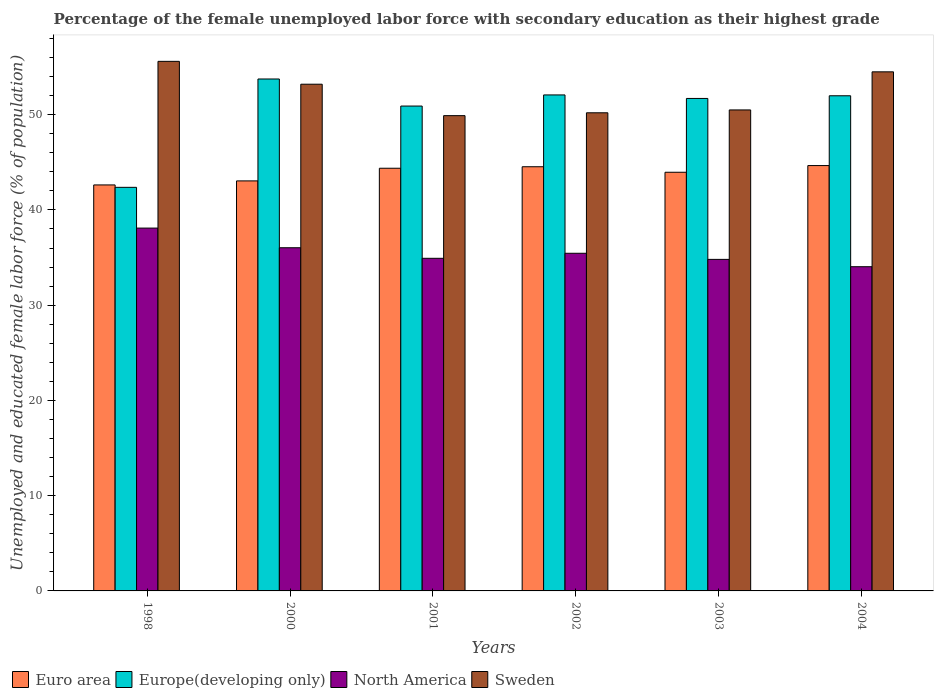Are the number of bars on each tick of the X-axis equal?
Offer a very short reply. Yes. What is the label of the 5th group of bars from the left?
Your response must be concise. 2003. In how many cases, is the number of bars for a given year not equal to the number of legend labels?
Your response must be concise. 0. What is the percentage of the unemployed female labor force with secondary education in North America in 2003?
Give a very brief answer. 34.81. Across all years, what is the maximum percentage of the unemployed female labor force with secondary education in Europe(developing only)?
Ensure brevity in your answer.  53.75. Across all years, what is the minimum percentage of the unemployed female labor force with secondary education in Europe(developing only)?
Provide a succinct answer. 42.37. What is the total percentage of the unemployed female labor force with secondary education in North America in the graph?
Give a very brief answer. 213.34. What is the difference between the percentage of the unemployed female labor force with secondary education in Euro area in 1998 and that in 2000?
Offer a very short reply. -0.42. What is the difference between the percentage of the unemployed female labor force with secondary education in North America in 2000 and the percentage of the unemployed female labor force with secondary education in Euro area in 2004?
Provide a short and direct response. -8.63. What is the average percentage of the unemployed female labor force with secondary education in North America per year?
Your answer should be compact. 35.56. In the year 2001, what is the difference between the percentage of the unemployed female labor force with secondary education in Europe(developing only) and percentage of the unemployed female labor force with secondary education in Euro area?
Your answer should be compact. 6.53. What is the ratio of the percentage of the unemployed female labor force with secondary education in North America in 2002 to that in 2004?
Offer a very short reply. 1.04. Is the percentage of the unemployed female labor force with secondary education in Euro area in 2002 less than that in 2003?
Offer a very short reply. No. What is the difference between the highest and the second highest percentage of the unemployed female labor force with secondary education in North America?
Offer a very short reply. 2.06. What is the difference between the highest and the lowest percentage of the unemployed female labor force with secondary education in Europe(developing only)?
Provide a short and direct response. 11.37. Is the sum of the percentage of the unemployed female labor force with secondary education in Sweden in 2001 and 2002 greater than the maximum percentage of the unemployed female labor force with secondary education in North America across all years?
Give a very brief answer. Yes. What does the 2nd bar from the left in 2001 represents?
Make the answer very short. Europe(developing only). What does the 2nd bar from the right in 2001 represents?
Your answer should be compact. North America. Is it the case that in every year, the sum of the percentage of the unemployed female labor force with secondary education in Euro area and percentage of the unemployed female labor force with secondary education in Europe(developing only) is greater than the percentage of the unemployed female labor force with secondary education in North America?
Your answer should be very brief. Yes. How many bars are there?
Your response must be concise. 24. Are all the bars in the graph horizontal?
Offer a terse response. No. What is the difference between two consecutive major ticks on the Y-axis?
Offer a terse response. 10. Does the graph contain any zero values?
Your answer should be compact. No. Does the graph contain grids?
Your answer should be compact. No. Where does the legend appear in the graph?
Your response must be concise. Bottom left. How are the legend labels stacked?
Ensure brevity in your answer.  Horizontal. What is the title of the graph?
Provide a succinct answer. Percentage of the female unemployed labor force with secondary education as their highest grade. What is the label or title of the X-axis?
Your response must be concise. Years. What is the label or title of the Y-axis?
Offer a terse response. Unemployed and educated female labor force (% of population). What is the Unemployed and educated female labor force (% of population) in Euro area in 1998?
Your response must be concise. 42.63. What is the Unemployed and educated female labor force (% of population) of Europe(developing only) in 1998?
Make the answer very short. 42.37. What is the Unemployed and educated female labor force (% of population) of North America in 1998?
Your answer should be very brief. 38.09. What is the Unemployed and educated female labor force (% of population) of Sweden in 1998?
Provide a short and direct response. 55.6. What is the Unemployed and educated female labor force (% of population) in Euro area in 2000?
Your answer should be compact. 43.05. What is the Unemployed and educated female labor force (% of population) in Europe(developing only) in 2000?
Offer a very short reply. 53.75. What is the Unemployed and educated female labor force (% of population) of North America in 2000?
Provide a succinct answer. 36.03. What is the Unemployed and educated female labor force (% of population) in Sweden in 2000?
Your answer should be very brief. 53.2. What is the Unemployed and educated female labor force (% of population) of Euro area in 2001?
Offer a very short reply. 44.38. What is the Unemployed and educated female labor force (% of population) in Europe(developing only) in 2001?
Your response must be concise. 50.91. What is the Unemployed and educated female labor force (% of population) of North America in 2001?
Offer a terse response. 34.92. What is the Unemployed and educated female labor force (% of population) of Sweden in 2001?
Your answer should be compact. 49.9. What is the Unemployed and educated female labor force (% of population) of Euro area in 2002?
Offer a very short reply. 44.53. What is the Unemployed and educated female labor force (% of population) in Europe(developing only) in 2002?
Your answer should be very brief. 52.07. What is the Unemployed and educated female labor force (% of population) in North America in 2002?
Provide a short and direct response. 35.45. What is the Unemployed and educated female labor force (% of population) in Sweden in 2002?
Give a very brief answer. 50.2. What is the Unemployed and educated female labor force (% of population) of Euro area in 2003?
Your answer should be very brief. 43.96. What is the Unemployed and educated female labor force (% of population) of Europe(developing only) in 2003?
Ensure brevity in your answer.  51.71. What is the Unemployed and educated female labor force (% of population) of North America in 2003?
Offer a very short reply. 34.81. What is the Unemployed and educated female labor force (% of population) in Sweden in 2003?
Give a very brief answer. 50.5. What is the Unemployed and educated female labor force (% of population) of Euro area in 2004?
Give a very brief answer. 44.66. What is the Unemployed and educated female labor force (% of population) of Europe(developing only) in 2004?
Offer a terse response. 51.99. What is the Unemployed and educated female labor force (% of population) of North America in 2004?
Offer a very short reply. 34.04. What is the Unemployed and educated female labor force (% of population) in Sweden in 2004?
Offer a very short reply. 54.5. Across all years, what is the maximum Unemployed and educated female labor force (% of population) in Euro area?
Your response must be concise. 44.66. Across all years, what is the maximum Unemployed and educated female labor force (% of population) of Europe(developing only)?
Offer a very short reply. 53.75. Across all years, what is the maximum Unemployed and educated female labor force (% of population) of North America?
Ensure brevity in your answer.  38.09. Across all years, what is the maximum Unemployed and educated female labor force (% of population) in Sweden?
Your answer should be very brief. 55.6. Across all years, what is the minimum Unemployed and educated female labor force (% of population) of Euro area?
Offer a terse response. 42.63. Across all years, what is the minimum Unemployed and educated female labor force (% of population) in Europe(developing only)?
Make the answer very short. 42.37. Across all years, what is the minimum Unemployed and educated female labor force (% of population) of North America?
Your response must be concise. 34.04. Across all years, what is the minimum Unemployed and educated female labor force (% of population) of Sweden?
Offer a terse response. 49.9. What is the total Unemployed and educated female labor force (% of population) of Euro area in the graph?
Provide a succinct answer. 263.2. What is the total Unemployed and educated female labor force (% of population) of Europe(developing only) in the graph?
Make the answer very short. 302.79. What is the total Unemployed and educated female labor force (% of population) of North America in the graph?
Keep it short and to the point. 213.34. What is the total Unemployed and educated female labor force (% of population) in Sweden in the graph?
Give a very brief answer. 313.9. What is the difference between the Unemployed and educated female labor force (% of population) in Euro area in 1998 and that in 2000?
Offer a terse response. -0.42. What is the difference between the Unemployed and educated female labor force (% of population) in Europe(developing only) in 1998 and that in 2000?
Keep it short and to the point. -11.37. What is the difference between the Unemployed and educated female labor force (% of population) of North America in 1998 and that in 2000?
Your answer should be very brief. 2.06. What is the difference between the Unemployed and educated female labor force (% of population) in Sweden in 1998 and that in 2000?
Ensure brevity in your answer.  2.4. What is the difference between the Unemployed and educated female labor force (% of population) of Euro area in 1998 and that in 2001?
Keep it short and to the point. -1.75. What is the difference between the Unemployed and educated female labor force (% of population) in Europe(developing only) in 1998 and that in 2001?
Offer a very short reply. -8.53. What is the difference between the Unemployed and educated female labor force (% of population) in North America in 1998 and that in 2001?
Offer a very short reply. 3.17. What is the difference between the Unemployed and educated female labor force (% of population) of Euro area in 1998 and that in 2002?
Provide a short and direct response. -1.91. What is the difference between the Unemployed and educated female labor force (% of population) of Europe(developing only) in 1998 and that in 2002?
Offer a terse response. -9.7. What is the difference between the Unemployed and educated female labor force (% of population) in North America in 1998 and that in 2002?
Make the answer very short. 2.64. What is the difference between the Unemployed and educated female labor force (% of population) of Euro area in 1998 and that in 2003?
Offer a very short reply. -1.33. What is the difference between the Unemployed and educated female labor force (% of population) in Europe(developing only) in 1998 and that in 2003?
Ensure brevity in your answer.  -9.33. What is the difference between the Unemployed and educated female labor force (% of population) of North America in 1998 and that in 2003?
Your answer should be compact. 3.29. What is the difference between the Unemployed and educated female labor force (% of population) of Sweden in 1998 and that in 2003?
Offer a terse response. 5.1. What is the difference between the Unemployed and educated female labor force (% of population) in Euro area in 1998 and that in 2004?
Ensure brevity in your answer.  -2.03. What is the difference between the Unemployed and educated female labor force (% of population) of Europe(developing only) in 1998 and that in 2004?
Offer a terse response. -9.61. What is the difference between the Unemployed and educated female labor force (% of population) in North America in 1998 and that in 2004?
Make the answer very short. 4.05. What is the difference between the Unemployed and educated female labor force (% of population) of Euro area in 2000 and that in 2001?
Make the answer very short. -1.33. What is the difference between the Unemployed and educated female labor force (% of population) in Europe(developing only) in 2000 and that in 2001?
Your answer should be very brief. 2.84. What is the difference between the Unemployed and educated female labor force (% of population) in North America in 2000 and that in 2001?
Your response must be concise. 1.11. What is the difference between the Unemployed and educated female labor force (% of population) of Euro area in 2000 and that in 2002?
Make the answer very short. -1.48. What is the difference between the Unemployed and educated female labor force (% of population) of Europe(developing only) in 2000 and that in 2002?
Your answer should be very brief. 1.67. What is the difference between the Unemployed and educated female labor force (% of population) in North America in 2000 and that in 2002?
Offer a very short reply. 0.58. What is the difference between the Unemployed and educated female labor force (% of population) in Sweden in 2000 and that in 2002?
Ensure brevity in your answer.  3. What is the difference between the Unemployed and educated female labor force (% of population) in Euro area in 2000 and that in 2003?
Provide a succinct answer. -0.91. What is the difference between the Unemployed and educated female labor force (% of population) of Europe(developing only) in 2000 and that in 2003?
Keep it short and to the point. 2.04. What is the difference between the Unemployed and educated female labor force (% of population) of North America in 2000 and that in 2003?
Your answer should be compact. 1.22. What is the difference between the Unemployed and educated female labor force (% of population) of Sweden in 2000 and that in 2003?
Make the answer very short. 2.7. What is the difference between the Unemployed and educated female labor force (% of population) of Euro area in 2000 and that in 2004?
Keep it short and to the point. -1.61. What is the difference between the Unemployed and educated female labor force (% of population) in Europe(developing only) in 2000 and that in 2004?
Provide a succinct answer. 1.76. What is the difference between the Unemployed and educated female labor force (% of population) of North America in 2000 and that in 2004?
Give a very brief answer. 1.99. What is the difference between the Unemployed and educated female labor force (% of population) of Sweden in 2000 and that in 2004?
Give a very brief answer. -1.3. What is the difference between the Unemployed and educated female labor force (% of population) of Euro area in 2001 and that in 2002?
Your answer should be compact. -0.16. What is the difference between the Unemployed and educated female labor force (% of population) of Europe(developing only) in 2001 and that in 2002?
Offer a terse response. -1.17. What is the difference between the Unemployed and educated female labor force (% of population) in North America in 2001 and that in 2002?
Offer a terse response. -0.53. What is the difference between the Unemployed and educated female labor force (% of population) of Sweden in 2001 and that in 2002?
Give a very brief answer. -0.3. What is the difference between the Unemployed and educated female labor force (% of population) of Euro area in 2001 and that in 2003?
Give a very brief answer. 0.42. What is the difference between the Unemployed and educated female labor force (% of population) in Europe(developing only) in 2001 and that in 2003?
Ensure brevity in your answer.  -0.8. What is the difference between the Unemployed and educated female labor force (% of population) of North America in 2001 and that in 2003?
Give a very brief answer. 0.11. What is the difference between the Unemployed and educated female labor force (% of population) in Sweden in 2001 and that in 2003?
Your answer should be very brief. -0.6. What is the difference between the Unemployed and educated female labor force (% of population) in Euro area in 2001 and that in 2004?
Your answer should be compact. -0.28. What is the difference between the Unemployed and educated female labor force (% of population) of Europe(developing only) in 2001 and that in 2004?
Your response must be concise. -1.08. What is the difference between the Unemployed and educated female labor force (% of population) of North America in 2001 and that in 2004?
Offer a terse response. 0.88. What is the difference between the Unemployed and educated female labor force (% of population) in Sweden in 2001 and that in 2004?
Your answer should be compact. -4.6. What is the difference between the Unemployed and educated female labor force (% of population) of Euro area in 2002 and that in 2003?
Your answer should be compact. 0.58. What is the difference between the Unemployed and educated female labor force (% of population) of Europe(developing only) in 2002 and that in 2003?
Provide a succinct answer. 0.37. What is the difference between the Unemployed and educated female labor force (% of population) of North America in 2002 and that in 2003?
Provide a short and direct response. 0.64. What is the difference between the Unemployed and educated female labor force (% of population) of Euro area in 2002 and that in 2004?
Provide a succinct answer. -0.12. What is the difference between the Unemployed and educated female labor force (% of population) of Europe(developing only) in 2002 and that in 2004?
Ensure brevity in your answer.  0.09. What is the difference between the Unemployed and educated female labor force (% of population) in North America in 2002 and that in 2004?
Provide a succinct answer. 1.41. What is the difference between the Unemployed and educated female labor force (% of population) in Euro area in 2003 and that in 2004?
Keep it short and to the point. -0.7. What is the difference between the Unemployed and educated female labor force (% of population) in Europe(developing only) in 2003 and that in 2004?
Provide a short and direct response. -0.28. What is the difference between the Unemployed and educated female labor force (% of population) in North America in 2003 and that in 2004?
Your answer should be compact. 0.77. What is the difference between the Unemployed and educated female labor force (% of population) in Euro area in 1998 and the Unemployed and educated female labor force (% of population) in Europe(developing only) in 2000?
Make the answer very short. -11.12. What is the difference between the Unemployed and educated female labor force (% of population) of Euro area in 1998 and the Unemployed and educated female labor force (% of population) of North America in 2000?
Your answer should be very brief. 6.59. What is the difference between the Unemployed and educated female labor force (% of population) of Euro area in 1998 and the Unemployed and educated female labor force (% of population) of Sweden in 2000?
Make the answer very short. -10.57. What is the difference between the Unemployed and educated female labor force (% of population) of Europe(developing only) in 1998 and the Unemployed and educated female labor force (% of population) of North America in 2000?
Give a very brief answer. 6.34. What is the difference between the Unemployed and educated female labor force (% of population) of Europe(developing only) in 1998 and the Unemployed and educated female labor force (% of population) of Sweden in 2000?
Your answer should be very brief. -10.83. What is the difference between the Unemployed and educated female labor force (% of population) in North America in 1998 and the Unemployed and educated female labor force (% of population) in Sweden in 2000?
Keep it short and to the point. -15.11. What is the difference between the Unemployed and educated female labor force (% of population) in Euro area in 1998 and the Unemployed and educated female labor force (% of population) in Europe(developing only) in 2001?
Your answer should be compact. -8.28. What is the difference between the Unemployed and educated female labor force (% of population) in Euro area in 1998 and the Unemployed and educated female labor force (% of population) in North America in 2001?
Offer a very short reply. 7.7. What is the difference between the Unemployed and educated female labor force (% of population) in Euro area in 1998 and the Unemployed and educated female labor force (% of population) in Sweden in 2001?
Your response must be concise. -7.27. What is the difference between the Unemployed and educated female labor force (% of population) of Europe(developing only) in 1998 and the Unemployed and educated female labor force (% of population) of North America in 2001?
Your response must be concise. 7.45. What is the difference between the Unemployed and educated female labor force (% of population) of Europe(developing only) in 1998 and the Unemployed and educated female labor force (% of population) of Sweden in 2001?
Make the answer very short. -7.53. What is the difference between the Unemployed and educated female labor force (% of population) in North America in 1998 and the Unemployed and educated female labor force (% of population) in Sweden in 2001?
Your answer should be very brief. -11.81. What is the difference between the Unemployed and educated female labor force (% of population) of Euro area in 1998 and the Unemployed and educated female labor force (% of population) of Europe(developing only) in 2002?
Provide a short and direct response. -9.45. What is the difference between the Unemployed and educated female labor force (% of population) of Euro area in 1998 and the Unemployed and educated female labor force (% of population) of North America in 2002?
Your answer should be very brief. 7.18. What is the difference between the Unemployed and educated female labor force (% of population) of Euro area in 1998 and the Unemployed and educated female labor force (% of population) of Sweden in 2002?
Make the answer very short. -7.57. What is the difference between the Unemployed and educated female labor force (% of population) in Europe(developing only) in 1998 and the Unemployed and educated female labor force (% of population) in North America in 2002?
Your answer should be very brief. 6.92. What is the difference between the Unemployed and educated female labor force (% of population) in Europe(developing only) in 1998 and the Unemployed and educated female labor force (% of population) in Sweden in 2002?
Provide a short and direct response. -7.83. What is the difference between the Unemployed and educated female labor force (% of population) of North America in 1998 and the Unemployed and educated female labor force (% of population) of Sweden in 2002?
Offer a very short reply. -12.11. What is the difference between the Unemployed and educated female labor force (% of population) of Euro area in 1998 and the Unemployed and educated female labor force (% of population) of Europe(developing only) in 2003?
Your answer should be compact. -9.08. What is the difference between the Unemployed and educated female labor force (% of population) of Euro area in 1998 and the Unemployed and educated female labor force (% of population) of North America in 2003?
Provide a short and direct response. 7.82. What is the difference between the Unemployed and educated female labor force (% of population) in Euro area in 1998 and the Unemployed and educated female labor force (% of population) in Sweden in 2003?
Ensure brevity in your answer.  -7.87. What is the difference between the Unemployed and educated female labor force (% of population) in Europe(developing only) in 1998 and the Unemployed and educated female labor force (% of population) in North America in 2003?
Ensure brevity in your answer.  7.56. What is the difference between the Unemployed and educated female labor force (% of population) in Europe(developing only) in 1998 and the Unemployed and educated female labor force (% of population) in Sweden in 2003?
Give a very brief answer. -8.13. What is the difference between the Unemployed and educated female labor force (% of population) of North America in 1998 and the Unemployed and educated female labor force (% of population) of Sweden in 2003?
Provide a succinct answer. -12.41. What is the difference between the Unemployed and educated female labor force (% of population) in Euro area in 1998 and the Unemployed and educated female labor force (% of population) in Europe(developing only) in 2004?
Your answer should be compact. -9.36. What is the difference between the Unemployed and educated female labor force (% of population) in Euro area in 1998 and the Unemployed and educated female labor force (% of population) in North America in 2004?
Your response must be concise. 8.59. What is the difference between the Unemployed and educated female labor force (% of population) in Euro area in 1998 and the Unemployed and educated female labor force (% of population) in Sweden in 2004?
Your answer should be compact. -11.87. What is the difference between the Unemployed and educated female labor force (% of population) in Europe(developing only) in 1998 and the Unemployed and educated female labor force (% of population) in North America in 2004?
Your response must be concise. 8.33. What is the difference between the Unemployed and educated female labor force (% of population) of Europe(developing only) in 1998 and the Unemployed and educated female labor force (% of population) of Sweden in 2004?
Your answer should be very brief. -12.13. What is the difference between the Unemployed and educated female labor force (% of population) of North America in 1998 and the Unemployed and educated female labor force (% of population) of Sweden in 2004?
Make the answer very short. -16.41. What is the difference between the Unemployed and educated female labor force (% of population) of Euro area in 2000 and the Unemployed and educated female labor force (% of population) of Europe(developing only) in 2001?
Your response must be concise. -7.86. What is the difference between the Unemployed and educated female labor force (% of population) in Euro area in 2000 and the Unemployed and educated female labor force (% of population) in North America in 2001?
Provide a succinct answer. 8.13. What is the difference between the Unemployed and educated female labor force (% of population) in Euro area in 2000 and the Unemployed and educated female labor force (% of population) in Sweden in 2001?
Offer a terse response. -6.85. What is the difference between the Unemployed and educated female labor force (% of population) in Europe(developing only) in 2000 and the Unemployed and educated female labor force (% of population) in North America in 2001?
Keep it short and to the point. 18.83. What is the difference between the Unemployed and educated female labor force (% of population) of Europe(developing only) in 2000 and the Unemployed and educated female labor force (% of population) of Sweden in 2001?
Your response must be concise. 3.85. What is the difference between the Unemployed and educated female labor force (% of population) in North America in 2000 and the Unemployed and educated female labor force (% of population) in Sweden in 2001?
Your answer should be compact. -13.87. What is the difference between the Unemployed and educated female labor force (% of population) of Euro area in 2000 and the Unemployed and educated female labor force (% of population) of Europe(developing only) in 2002?
Offer a very short reply. -9.03. What is the difference between the Unemployed and educated female labor force (% of population) in Euro area in 2000 and the Unemployed and educated female labor force (% of population) in North America in 2002?
Offer a terse response. 7.6. What is the difference between the Unemployed and educated female labor force (% of population) in Euro area in 2000 and the Unemployed and educated female labor force (% of population) in Sweden in 2002?
Your response must be concise. -7.15. What is the difference between the Unemployed and educated female labor force (% of population) in Europe(developing only) in 2000 and the Unemployed and educated female labor force (% of population) in North America in 2002?
Provide a short and direct response. 18.3. What is the difference between the Unemployed and educated female labor force (% of population) in Europe(developing only) in 2000 and the Unemployed and educated female labor force (% of population) in Sweden in 2002?
Your answer should be very brief. 3.55. What is the difference between the Unemployed and educated female labor force (% of population) in North America in 2000 and the Unemployed and educated female labor force (% of population) in Sweden in 2002?
Make the answer very short. -14.17. What is the difference between the Unemployed and educated female labor force (% of population) in Euro area in 2000 and the Unemployed and educated female labor force (% of population) in Europe(developing only) in 2003?
Keep it short and to the point. -8.66. What is the difference between the Unemployed and educated female labor force (% of population) of Euro area in 2000 and the Unemployed and educated female labor force (% of population) of North America in 2003?
Keep it short and to the point. 8.24. What is the difference between the Unemployed and educated female labor force (% of population) of Euro area in 2000 and the Unemployed and educated female labor force (% of population) of Sweden in 2003?
Your response must be concise. -7.45. What is the difference between the Unemployed and educated female labor force (% of population) of Europe(developing only) in 2000 and the Unemployed and educated female labor force (% of population) of North America in 2003?
Provide a short and direct response. 18.94. What is the difference between the Unemployed and educated female labor force (% of population) of Europe(developing only) in 2000 and the Unemployed and educated female labor force (% of population) of Sweden in 2003?
Provide a short and direct response. 3.25. What is the difference between the Unemployed and educated female labor force (% of population) in North America in 2000 and the Unemployed and educated female labor force (% of population) in Sweden in 2003?
Keep it short and to the point. -14.47. What is the difference between the Unemployed and educated female labor force (% of population) in Euro area in 2000 and the Unemployed and educated female labor force (% of population) in Europe(developing only) in 2004?
Give a very brief answer. -8.94. What is the difference between the Unemployed and educated female labor force (% of population) in Euro area in 2000 and the Unemployed and educated female labor force (% of population) in North America in 2004?
Give a very brief answer. 9.01. What is the difference between the Unemployed and educated female labor force (% of population) in Euro area in 2000 and the Unemployed and educated female labor force (% of population) in Sweden in 2004?
Keep it short and to the point. -11.45. What is the difference between the Unemployed and educated female labor force (% of population) of Europe(developing only) in 2000 and the Unemployed and educated female labor force (% of population) of North America in 2004?
Provide a succinct answer. 19.71. What is the difference between the Unemployed and educated female labor force (% of population) in Europe(developing only) in 2000 and the Unemployed and educated female labor force (% of population) in Sweden in 2004?
Your answer should be compact. -0.75. What is the difference between the Unemployed and educated female labor force (% of population) in North America in 2000 and the Unemployed and educated female labor force (% of population) in Sweden in 2004?
Your answer should be very brief. -18.47. What is the difference between the Unemployed and educated female labor force (% of population) in Euro area in 2001 and the Unemployed and educated female labor force (% of population) in Europe(developing only) in 2002?
Your response must be concise. -7.7. What is the difference between the Unemployed and educated female labor force (% of population) of Euro area in 2001 and the Unemployed and educated female labor force (% of population) of North America in 2002?
Provide a succinct answer. 8.93. What is the difference between the Unemployed and educated female labor force (% of population) of Euro area in 2001 and the Unemployed and educated female labor force (% of population) of Sweden in 2002?
Your response must be concise. -5.82. What is the difference between the Unemployed and educated female labor force (% of population) of Europe(developing only) in 2001 and the Unemployed and educated female labor force (% of population) of North America in 2002?
Your answer should be compact. 15.46. What is the difference between the Unemployed and educated female labor force (% of population) in Europe(developing only) in 2001 and the Unemployed and educated female labor force (% of population) in Sweden in 2002?
Keep it short and to the point. 0.71. What is the difference between the Unemployed and educated female labor force (% of population) in North America in 2001 and the Unemployed and educated female labor force (% of population) in Sweden in 2002?
Your answer should be very brief. -15.28. What is the difference between the Unemployed and educated female labor force (% of population) of Euro area in 2001 and the Unemployed and educated female labor force (% of population) of Europe(developing only) in 2003?
Provide a short and direct response. -7.33. What is the difference between the Unemployed and educated female labor force (% of population) of Euro area in 2001 and the Unemployed and educated female labor force (% of population) of North America in 2003?
Offer a terse response. 9.57. What is the difference between the Unemployed and educated female labor force (% of population) in Euro area in 2001 and the Unemployed and educated female labor force (% of population) in Sweden in 2003?
Offer a very short reply. -6.12. What is the difference between the Unemployed and educated female labor force (% of population) of Europe(developing only) in 2001 and the Unemployed and educated female labor force (% of population) of North America in 2003?
Provide a succinct answer. 16.1. What is the difference between the Unemployed and educated female labor force (% of population) of Europe(developing only) in 2001 and the Unemployed and educated female labor force (% of population) of Sweden in 2003?
Your answer should be compact. 0.41. What is the difference between the Unemployed and educated female labor force (% of population) of North America in 2001 and the Unemployed and educated female labor force (% of population) of Sweden in 2003?
Keep it short and to the point. -15.58. What is the difference between the Unemployed and educated female labor force (% of population) in Euro area in 2001 and the Unemployed and educated female labor force (% of population) in Europe(developing only) in 2004?
Your answer should be compact. -7.61. What is the difference between the Unemployed and educated female labor force (% of population) of Euro area in 2001 and the Unemployed and educated female labor force (% of population) of North America in 2004?
Your answer should be compact. 10.34. What is the difference between the Unemployed and educated female labor force (% of population) of Euro area in 2001 and the Unemployed and educated female labor force (% of population) of Sweden in 2004?
Your response must be concise. -10.12. What is the difference between the Unemployed and educated female labor force (% of population) of Europe(developing only) in 2001 and the Unemployed and educated female labor force (% of population) of North America in 2004?
Ensure brevity in your answer.  16.87. What is the difference between the Unemployed and educated female labor force (% of population) in Europe(developing only) in 2001 and the Unemployed and educated female labor force (% of population) in Sweden in 2004?
Give a very brief answer. -3.59. What is the difference between the Unemployed and educated female labor force (% of population) in North America in 2001 and the Unemployed and educated female labor force (% of population) in Sweden in 2004?
Provide a short and direct response. -19.58. What is the difference between the Unemployed and educated female labor force (% of population) of Euro area in 2002 and the Unemployed and educated female labor force (% of population) of Europe(developing only) in 2003?
Offer a terse response. -7.17. What is the difference between the Unemployed and educated female labor force (% of population) of Euro area in 2002 and the Unemployed and educated female labor force (% of population) of North America in 2003?
Provide a short and direct response. 9.73. What is the difference between the Unemployed and educated female labor force (% of population) in Euro area in 2002 and the Unemployed and educated female labor force (% of population) in Sweden in 2003?
Ensure brevity in your answer.  -5.97. What is the difference between the Unemployed and educated female labor force (% of population) of Europe(developing only) in 2002 and the Unemployed and educated female labor force (% of population) of North America in 2003?
Provide a succinct answer. 17.27. What is the difference between the Unemployed and educated female labor force (% of population) in Europe(developing only) in 2002 and the Unemployed and educated female labor force (% of population) in Sweden in 2003?
Ensure brevity in your answer.  1.57. What is the difference between the Unemployed and educated female labor force (% of population) of North America in 2002 and the Unemployed and educated female labor force (% of population) of Sweden in 2003?
Provide a short and direct response. -15.05. What is the difference between the Unemployed and educated female labor force (% of population) of Euro area in 2002 and the Unemployed and educated female labor force (% of population) of Europe(developing only) in 2004?
Your response must be concise. -7.45. What is the difference between the Unemployed and educated female labor force (% of population) in Euro area in 2002 and the Unemployed and educated female labor force (% of population) in North America in 2004?
Make the answer very short. 10.5. What is the difference between the Unemployed and educated female labor force (% of population) in Euro area in 2002 and the Unemployed and educated female labor force (% of population) in Sweden in 2004?
Your answer should be very brief. -9.97. What is the difference between the Unemployed and educated female labor force (% of population) in Europe(developing only) in 2002 and the Unemployed and educated female labor force (% of population) in North America in 2004?
Ensure brevity in your answer.  18.04. What is the difference between the Unemployed and educated female labor force (% of population) of Europe(developing only) in 2002 and the Unemployed and educated female labor force (% of population) of Sweden in 2004?
Your answer should be very brief. -2.43. What is the difference between the Unemployed and educated female labor force (% of population) in North America in 2002 and the Unemployed and educated female labor force (% of population) in Sweden in 2004?
Keep it short and to the point. -19.05. What is the difference between the Unemployed and educated female labor force (% of population) of Euro area in 2003 and the Unemployed and educated female labor force (% of population) of Europe(developing only) in 2004?
Your answer should be very brief. -8.03. What is the difference between the Unemployed and educated female labor force (% of population) in Euro area in 2003 and the Unemployed and educated female labor force (% of population) in North America in 2004?
Keep it short and to the point. 9.92. What is the difference between the Unemployed and educated female labor force (% of population) of Euro area in 2003 and the Unemployed and educated female labor force (% of population) of Sweden in 2004?
Ensure brevity in your answer.  -10.54. What is the difference between the Unemployed and educated female labor force (% of population) in Europe(developing only) in 2003 and the Unemployed and educated female labor force (% of population) in North America in 2004?
Give a very brief answer. 17.67. What is the difference between the Unemployed and educated female labor force (% of population) in Europe(developing only) in 2003 and the Unemployed and educated female labor force (% of population) in Sweden in 2004?
Give a very brief answer. -2.79. What is the difference between the Unemployed and educated female labor force (% of population) of North America in 2003 and the Unemployed and educated female labor force (% of population) of Sweden in 2004?
Provide a succinct answer. -19.69. What is the average Unemployed and educated female labor force (% of population) of Euro area per year?
Make the answer very short. 43.87. What is the average Unemployed and educated female labor force (% of population) of Europe(developing only) per year?
Make the answer very short. 50.47. What is the average Unemployed and educated female labor force (% of population) of North America per year?
Give a very brief answer. 35.56. What is the average Unemployed and educated female labor force (% of population) in Sweden per year?
Offer a terse response. 52.32. In the year 1998, what is the difference between the Unemployed and educated female labor force (% of population) in Euro area and Unemployed and educated female labor force (% of population) in Europe(developing only)?
Your answer should be compact. 0.25. In the year 1998, what is the difference between the Unemployed and educated female labor force (% of population) of Euro area and Unemployed and educated female labor force (% of population) of North America?
Your answer should be very brief. 4.53. In the year 1998, what is the difference between the Unemployed and educated female labor force (% of population) of Euro area and Unemployed and educated female labor force (% of population) of Sweden?
Your answer should be compact. -12.97. In the year 1998, what is the difference between the Unemployed and educated female labor force (% of population) of Europe(developing only) and Unemployed and educated female labor force (% of population) of North America?
Ensure brevity in your answer.  4.28. In the year 1998, what is the difference between the Unemployed and educated female labor force (% of population) in Europe(developing only) and Unemployed and educated female labor force (% of population) in Sweden?
Your answer should be very brief. -13.23. In the year 1998, what is the difference between the Unemployed and educated female labor force (% of population) in North America and Unemployed and educated female labor force (% of population) in Sweden?
Provide a succinct answer. -17.51. In the year 2000, what is the difference between the Unemployed and educated female labor force (% of population) of Euro area and Unemployed and educated female labor force (% of population) of Europe(developing only)?
Your response must be concise. -10.7. In the year 2000, what is the difference between the Unemployed and educated female labor force (% of population) in Euro area and Unemployed and educated female labor force (% of population) in North America?
Your answer should be very brief. 7.02. In the year 2000, what is the difference between the Unemployed and educated female labor force (% of population) of Euro area and Unemployed and educated female labor force (% of population) of Sweden?
Keep it short and to the point. -10.15. In the year 2000, what is the difference between the Unemployed and educated female labor force (% of population) in Europe(developing only) and Unemployed and educated female labor force (% of population) in North America?
Ensure brevity in your answer.  17.72. In the year 2000, what is the difference between the Unemployed and educated female labor force (% of population) of Europe(developing only) and Unemployed and educated female labor force (% of population) of Sweden?
Provide a short and direct response. 0.55. In the year 2000, what is the difference between the Unemployed and educated female labor force (% of population) of North America and Unemployed and educated female labor force (% of population) of Sweden?
Give a very brief answer. -17.17. In the year 2001, what is the difference between the Unemployed and educated female labor force (% of population) of Euro area and Unemployed and educated female labor force (% of population) of Europe(developing only)?
Your response must be concise. -6.53. In the year 2001, what is the difference between the Unemployed and educated female labor force (% of population) of Euro area and Unemployed and educated female labor force (% of population) of North America?
Your answer should be compact. 9.46. In the year 2001, what is the difference between the Unemployed and educated female labor force (% of population) of Euro area and Unemployed and educated female labor force (% of population) of Sweden?
Keep it short and to the point. -5.52. In the year 2001, what is the difference between the Unemployed and educated female labor force (% of population) of Europe(developing only) and Unemployed and educated female labor force (% of population) of North America?
Make the answer very short. 15.98. In the year 2001, what is the difference between the Unemployed and educated female labor force (% of population) in North America and Unemployed and educated female labor force (% of population) in Sweden?
Ensure brevity in your answer.  -14.98. In the year 2002, what is the difference between the Unemployed and educated female labor force (% of population) of Euro area and Unemployed and educated female labor force (% of population) of Europe(developing only)?
Offer a very short reply. -7.54. In the year 2002, what is the difference between the Unemployed and educated female labor force (% of population) in Euro area and Unemployed and educated female labor force (% of population) in North America?
Offer a very short reply. 9.09. In the year 2002, what is the difference between the Unemployed and educated female labor force (% of population) of Euro area and Unemployed and educated female labor force (% of population) of Sweden?
Provide a short and direct response. -5.67. In the year 2002, what is the difference between the Unemployed and educated female labor force (% of population) of Europe(developing only) and Unemployed and educated female labor force (% of population) of North America?
Your response must be concise. 16.63. In the year 2002, what is the difference between the Unemployed and educated female labor force (% of population) in Europe(developing only) and Unemployed and educated female labor force (% of population) in Sweden?
Keep it short and to the point. 1.87. In the year 2002, what is the difference between the Unemployed and educated female labor force (% of population) of North America and Unemployed and educated female labor force (% of population) of Sweden?
Make the answer very short. -14.75. In the year 2003, what is the difference between the Unemployed and educated female labor force (% of population) of Euro area and Unemployed and educated female labor force (% of population) of Europe(developing only)?
Keep it short and to the point. -7.75. In the year 2003, what is the difference between the Unemployed and educated female labor force (% of population) of Euro area and Unemployed and educated female labor force (% of population) of North America?
Keep it short and to the point. 9.15. In the year 2003, what is the difference between the Unemployed and educated female labor force (% of population) of Euro area and Unemployed and educated female labor force (% of population) of Sweden?
Give a very brief answer. -6.54. In the year 2003, what is the difference between the Unemployed and educated female labor force (% of population) in Europe(developing only) and Unemployed and educated female labor force (% of population) in North America?
Provide a short and direct response. 16.9. In the year 2003, what is the difference between the Unemployed and educated female labor force (% of population) in Europe(developing only) and Unemployed and educated female labor force (% of population) in Sweden?
Ensure brevity in your answer.  1.21. In the year 2003, what is the difference between the Unemployed and educated female labor force (% of population) in North America and Unemployed and educated female labor force (% of population) in Sweden?
Ensure brevity in your answer.  -15.69. In the year 2004, what is the difference between the Unemployed and educated female labor force (% of population) in Euro area and Unemployed and educated female labor force (% of population) in Europe(developing only)?
Keep it short and to the point. -7.33. In the year 2004, what is the difference between the Unemployed and educated female labor force (% of population) in Euro area and Unemployed and educated female labor force (% of population) in North America?
Your answer should be compact. 10.62. In the year 2004, what is the difference between the Unemployed and educated female labor force (% of population) of Euro area and Unemployed and educated female labor force (% of population) of Sweden?
Give a very brief answer. -9.84. In the year 2004, what is the difference between the Unemployed and educated female labor force (% of population) of Europe(developing only) and Unemployed and educated female labor force (% of population) of North America?
Ensure brevity in your answer.  17.95. In the year 2004, what is the difference between the Unemployed and educated female labor force (% of population) of Europe(developing only) and Unemployed and educated female labor force (% of population) of Sweden?
Provide a short and direct response. -2.51. In the year 2004, what is the difference between the Unemployed and educated female labor force (% of population) in North America and Unemployed and educated female labor force (% of population) in Sweden?
Offer a very short reply. -20.46. What is the ratio of the Unemployed and educated female labor force (% of population) of Euro area in 1998 to that in 2000?
Offer a very short reply. 0.99. What is the ratio of the Unemployed and educated female labor force (% of population) in Europe(developing only) in 1998 to that in 2000?
Your response must be concise. 0.79. What is the ratio of the Unemployed and educated female labor force (% of population) of North America in 1998 to that in 2000?
Provide a short and direct response. 1.06. What is the ratio of the Unemployed and educated female labor force (% of population) of Sweden in 1998 to that in 2000?
Provide a succinct answer. 1.05. What is the ratio of the Unemployed and educated female labor force (% of population) in Euro area in 1998 to that in 2001?
Provide a short and direct response. 0.96. What is the ratio of the Unemployed and educated female labor force (% of population) of Europe(developing only) in 1998 to that in 2001?
Offer a very short reply. 0.83. What is the ratio of the Unemployed and educated female labor force (% of population) of North America in 1998 to that in 2001?
Your answer should be very brief. 1.09. What is the ratio of the Unemployed and educated female labor force (% of population) in Sweden in 1998 to that in 2001?
Provide a succinct answer. 1.11. What is the ratio of the Unemployed and educated female labor force (% of population) in Euro area in 1998 to that in 2002?
Provide a succinct answer. 0.96. What is the ratio of the Unemployed and educated female labor force (% of population) of Europe(developing only) in 1998 to that in 2002?
Offer a terse response. 0.81. What is the ratio of the Unemployed and educated female labor force (% of population) in North America in 1998 to that in 2002?
Offer a very short reply. 1.07. What is the ratio of the Unemployed and educated female labor force (% of population) of Sweden in 1998 to that in 2002?
Your answer should be very brief. 1.11. What is the ratio of the Unemployed and educated female labor force (% of population) of Euro area in 1998 to that in 2003?
Offer a terse response. 0.97. What is the ratio of the Unemployed and educated female labor force (% of population) in Europe(developing only) in 1998 to that in 2003?
Offer a terse response. 0.82. What is the ratio of the Unemployed and educated female labor force (% of population) of North America in 1998 to that in 2003?
Your answer should be compact. 1.09. What is the ratio of the Unemployed and educated female labor force (% of population) of Sweden in 1998 to that in 2003?
Your response must be concise. 1.1. What is the ratio of the Unemployed and educated female labor force (% of population) of Euro area in 1998 to that in 2004?
Ensure brevity in your answer.  0.95. What is the ratio of the Unemployed and educated female labor force (% of population) in Europe(developing only) in 1998 to that in 2004?
Your answer should be very brief. 0.82. What is the ratio of the Unemployed and educated female labor force (% of population) in North America in 1998 to that in 2004?
Provide a succinct answer. 1.12. What is the ratio of the Unemployed and educated female labor force (% of population) in Sweden in 1998 to that in 2004?
Provide a succinct answer. 1.02. What is the ratio of the Unemployed and educated female labor force (% of population) in Euro area in 2000 to that in 2001?
Provide a short and direct response. 0.97. What is the ratio of the Unemployed and educated female labor force (% of population) in Europe(developing only) in 2000 to that in 2001?
Ensure brevity in your answer.  1.06. What is the ratio of the Unemployed and educated female labor force (% of population) of North America in 2000 to that in 2001?
Offer a very short reply. 1.03. What is the ratio of the Unemployed and educated female labor force (% of population) of Sweden in 2000 to that in 2001?
Offer a terse response. 1.07. What is the ratio of the Unemployed and educated female labor force (% of population) of Euro area in 2000 to that in 2002?
Ensure brevity in your answer.  0.97. What is the ratio of the Unemployed and educated female labor force (% of population) in Europe(developing only) in 2000 to that in 2002?
Your response must be concise. 1.03. What is the ratio of the Unemployed and educated female labor force (% of population) of North America in 2000 to that in 2002?
Offer a terse response. 1.02. What is the ratio of the Unemployed and educated female labor force (% of population) of Sweden in 2000 to that in 2002?
Your answer should be compact. 1.06. What is the ratio of the Unemployed and educated female labor force (% of population) in Euro area in 2000 to that in 2003?
Provide a succinct answer. 0.98. What is the ratio of the Unemployed and educated female labor force (% of population) in Europe(developing only) in 2000 to that in 2003?
Your response must be concise. 1.04. What is the ratio of the Unemployed and educated female labor force (% of population) in North America in 2000 to that in 2003?
Make the answer very short. 1.04. What is the ratio of the Unemployed and educated female labor force (% of population) of Sweden in 2000 to that in 2003?
Your answer should be very brief. 1.05. What is the ratio of the Unemployed and educated female labor force (% of population) in Euro area in 2000 to that in 2004?
Your answer should be very brief. 0.96. What is the ratio of the Unemployed and educated female labor force (% of population) of Europe(developing only) in 2000 to that in 2004?
Your answer should be very brief. 1.03. What is the ratio of the Unemployed and educated female labor force (% of population) in North America in 2000 to that in 2004?
Give a very brief answer. 1.06. What is the ratio of the Unemployed and educated female labor force (% of population) of Sweden in 2000 to that in 2004?
Provide a succinct answer. 0.98. What is the ratio of the Unemployed and educated female labor force (% of population) of Euro area in 2001 to that in 2002?
Provide a short and direct response. 1. What is the ratio of the Unemployed and educated female labor force (% of population) in Europe(developing only) in 2001 to that in 2002?
Make the answer very short. 0.98. What is the ratio of the Unemployed and educated female labor force (% of population) in North America in 2001 to that in 2002?
Your response must be concise. 0.99. What is the ratio of the Unemployed and educated female labor force (% of population) in Euro area in 2001 to that in 2003?
Ensure brevity in your answer.  1.01. What is the ratio of the Unemployed and educated female labor force (% of population) in Europe(developing only) in 2001 to that in 2003?
Provide a short and direct response. 0.98. What is the ratio of the Unemployed and educated female labor force (% of population) of Euro area in 2001 to that in 2004?
Your answer should be very brief. 0.99. What is the ratio of the Unemployed and educated female labor force (% of population) in Europe(developing only) in 2001 to that in 2004?
Give a very brief answer. 0.98. What is the ratio of the Unemployed and educated female labor force (% of population) of North America in 2001 to that in 2004?
Offer a very short reply. 1.03. What is the ratio of the Unemployed and educated female labor force (% of population) of Sweden in 2001 to that in 2004?
Keep it short and to the point. 0.92. What is the ratio of the Unemployed and educated female labor force (% of population) in Euro area in 2002 to that in 2003?
Your answer should be very brief. 1.01. What is the ratio of the Unemployed and educated female labor force (% of population) in Europe(developing only) in 2002 to that in 2003?
Your response must be concise. 1.01. What is the ratio of the Unemployed and educated female labor force (% of population) in North America in 2002 to that in 2003?
Give a very brief answer. 1.02. What is the ratio of the Unemployed and educated female labor force (% of population) of Sweden in 2002 to that in 2003?
Ensure brevity in your answer.  0.99. What is the ratio of the Unemployed and educated female labor force (% of population) of North America in 2002 to that in 2004?
Make the answer very short. 1.04. What is the ratio of the Unemployed and educated female labor force (% of population) in Sweden in 2002 to that in 2004?
Your answer should be compact. 0.92. What is the ratio of the Unemployed and educated female labor force (% of population) of Euro area in 2003 to that in 2004?
Keep it short and to the point. 0.98. What is the ratio of the Unemployed and educated female labor force (% of population) in North America in 2003 to that in 2004?
Your answer should be compact. 1.02. What is the ratio of the Unemployed and educated female labor force (% of population) in Sweden in 2003 to that in 2004?
Your answer should be very brief. 0.93. What is the difference between the highest and the second highest Unemployed and educated female labor force (% of population) in Euro area?
Provide a short and direct response. 0.12. What is the difference between the highest and the second highest Unemployed and educated female labor force (% of population) of Europe(developing only)?
Ensure brevity in your answer.  1.67. What is the difference between the highest and the second highest Unemployed and educated female labor force (% of population) in North America?
Keep it short and to the point. 2.06. What is the difference between the highest and the lowest Unemployed and educated female labor force (% of population) of Euro area?
Keep it short and to the point. 2.03. What is the difference between the highest and the lowest Unemployed and educated female labor force (% of population) of Europe(developing only)?
Offer a terse response. 11.37. What is the difference between the highest and the lowest Unemployed and educated female labor force (% of population) of North America?
Keep it short and to the point. 4.05. What is the difference between the highest and the lowest Unemployed and educated female labor force (% of population) of Sweden?
Offer a terse response. 5.7. 